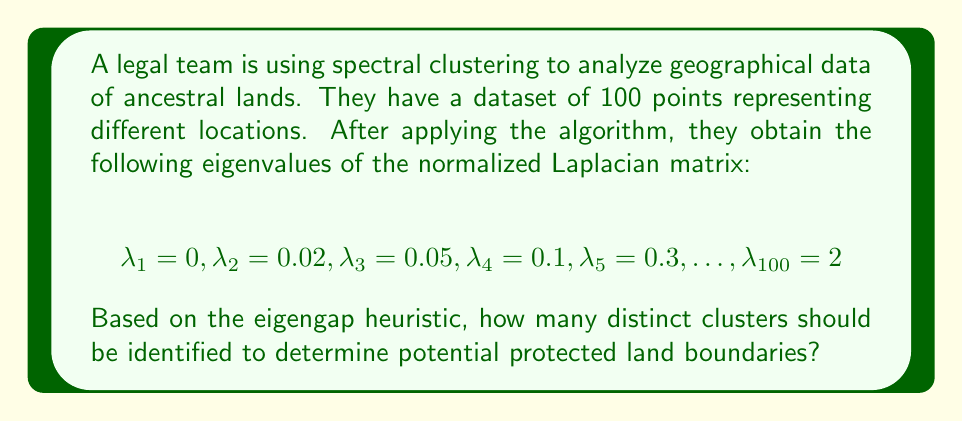Give your solution to this math problem. To solve this problem, we'll follow these steps:

1) Recall the eigengap heuristic: The number of clusters is determined by the number of eigenvalues before the largest gap in the spectrum.

2) Calculate the gaps between consecutive eigenvalues:
   $\lambda_2 - \lambda_1 = 0.02 - 0 = 0.02$
   $\lambda_3 - \lambda_2 = 0.05 - 0.02 = 0.03$
   $\lambda_4 - \lambda_3 = 0.1 - 0.05 = 0.05$
   $\lambda_5 - \lambda_4 = 0.3 - 0.1 = 0.2$

3) Identify the largest gap:
   The largest gap is between $\lambda_4$ and $\lambda_5$, with a value of 0.2.

4) Count the number of eigenvalues before this largest gap:
   There are 4 eigenvalues ($\lambda_1, \lambda_2, \lambda_3, \lambda_4$) before the largest gap.

5) Therefore, according to the eigengap heuristic, the number of clusters is 4.

This suggests that the geographical data of the ancestral lands can be optimally divided into 4 distinct regions or clusters, which could represent different protected land boundaries.
Answer: 4 clusters 